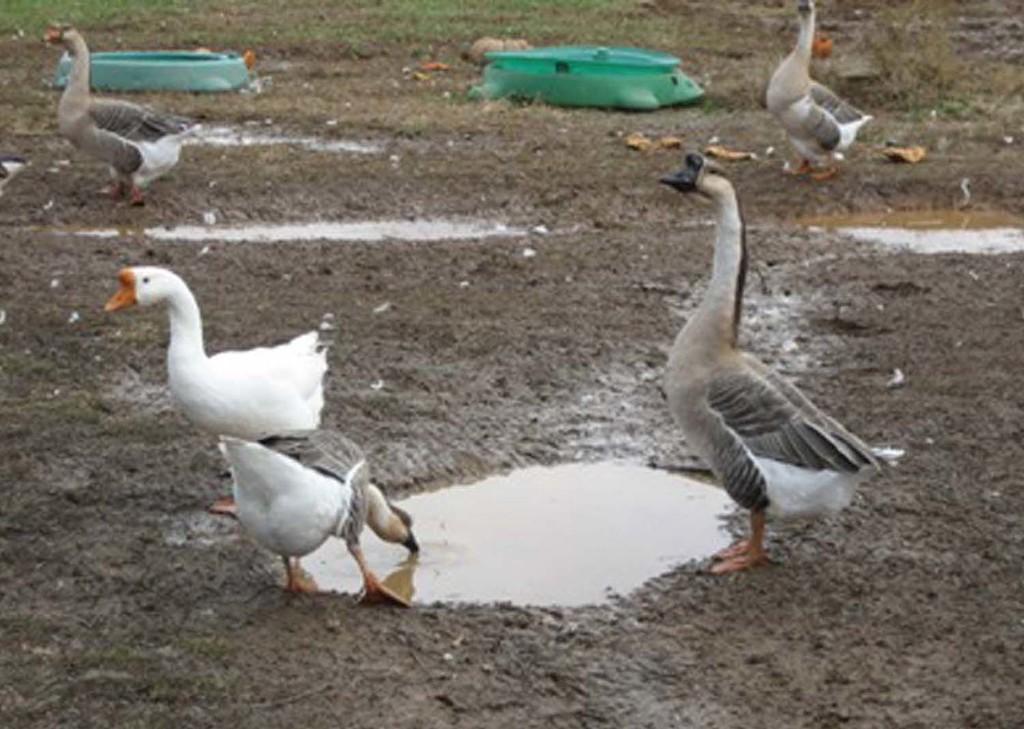How would you summarize this image in a sentence or two? In this image we can see ducks on the ground. 